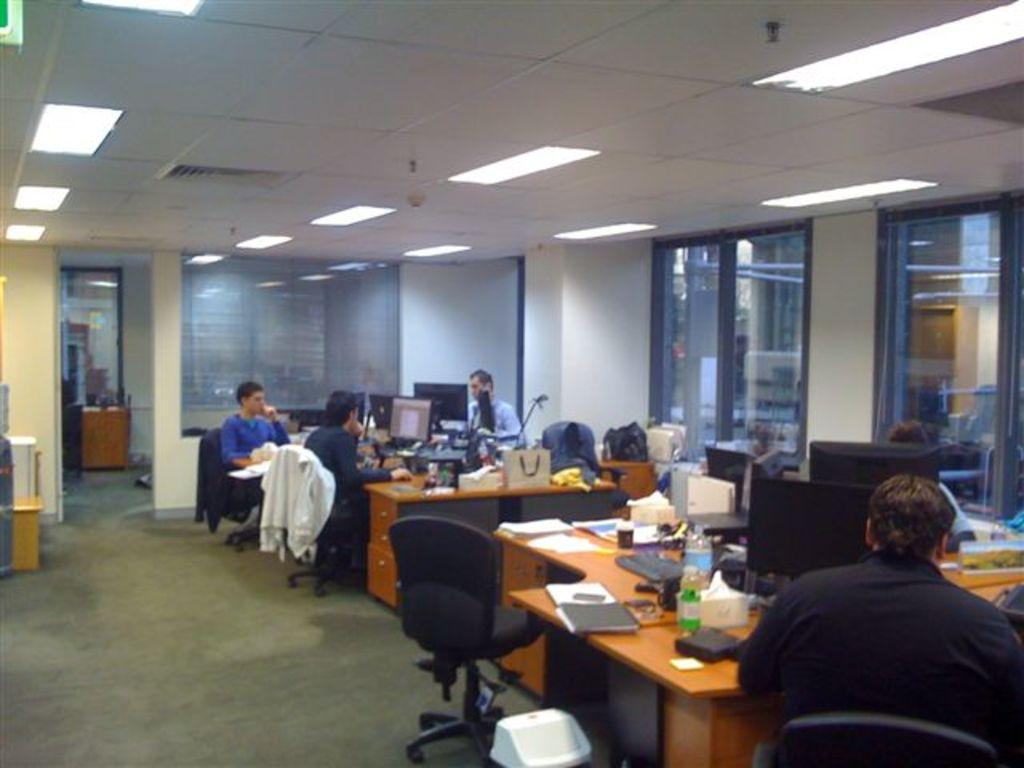Can you describe this image briefly? In the image we can see there are lot of people who are sitting on chair and table there is laptop, bag, bottle and file. 